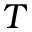Convert formula to latex. <formula><loc_0><loc_0><loc_500><loc_500>T</formula> 